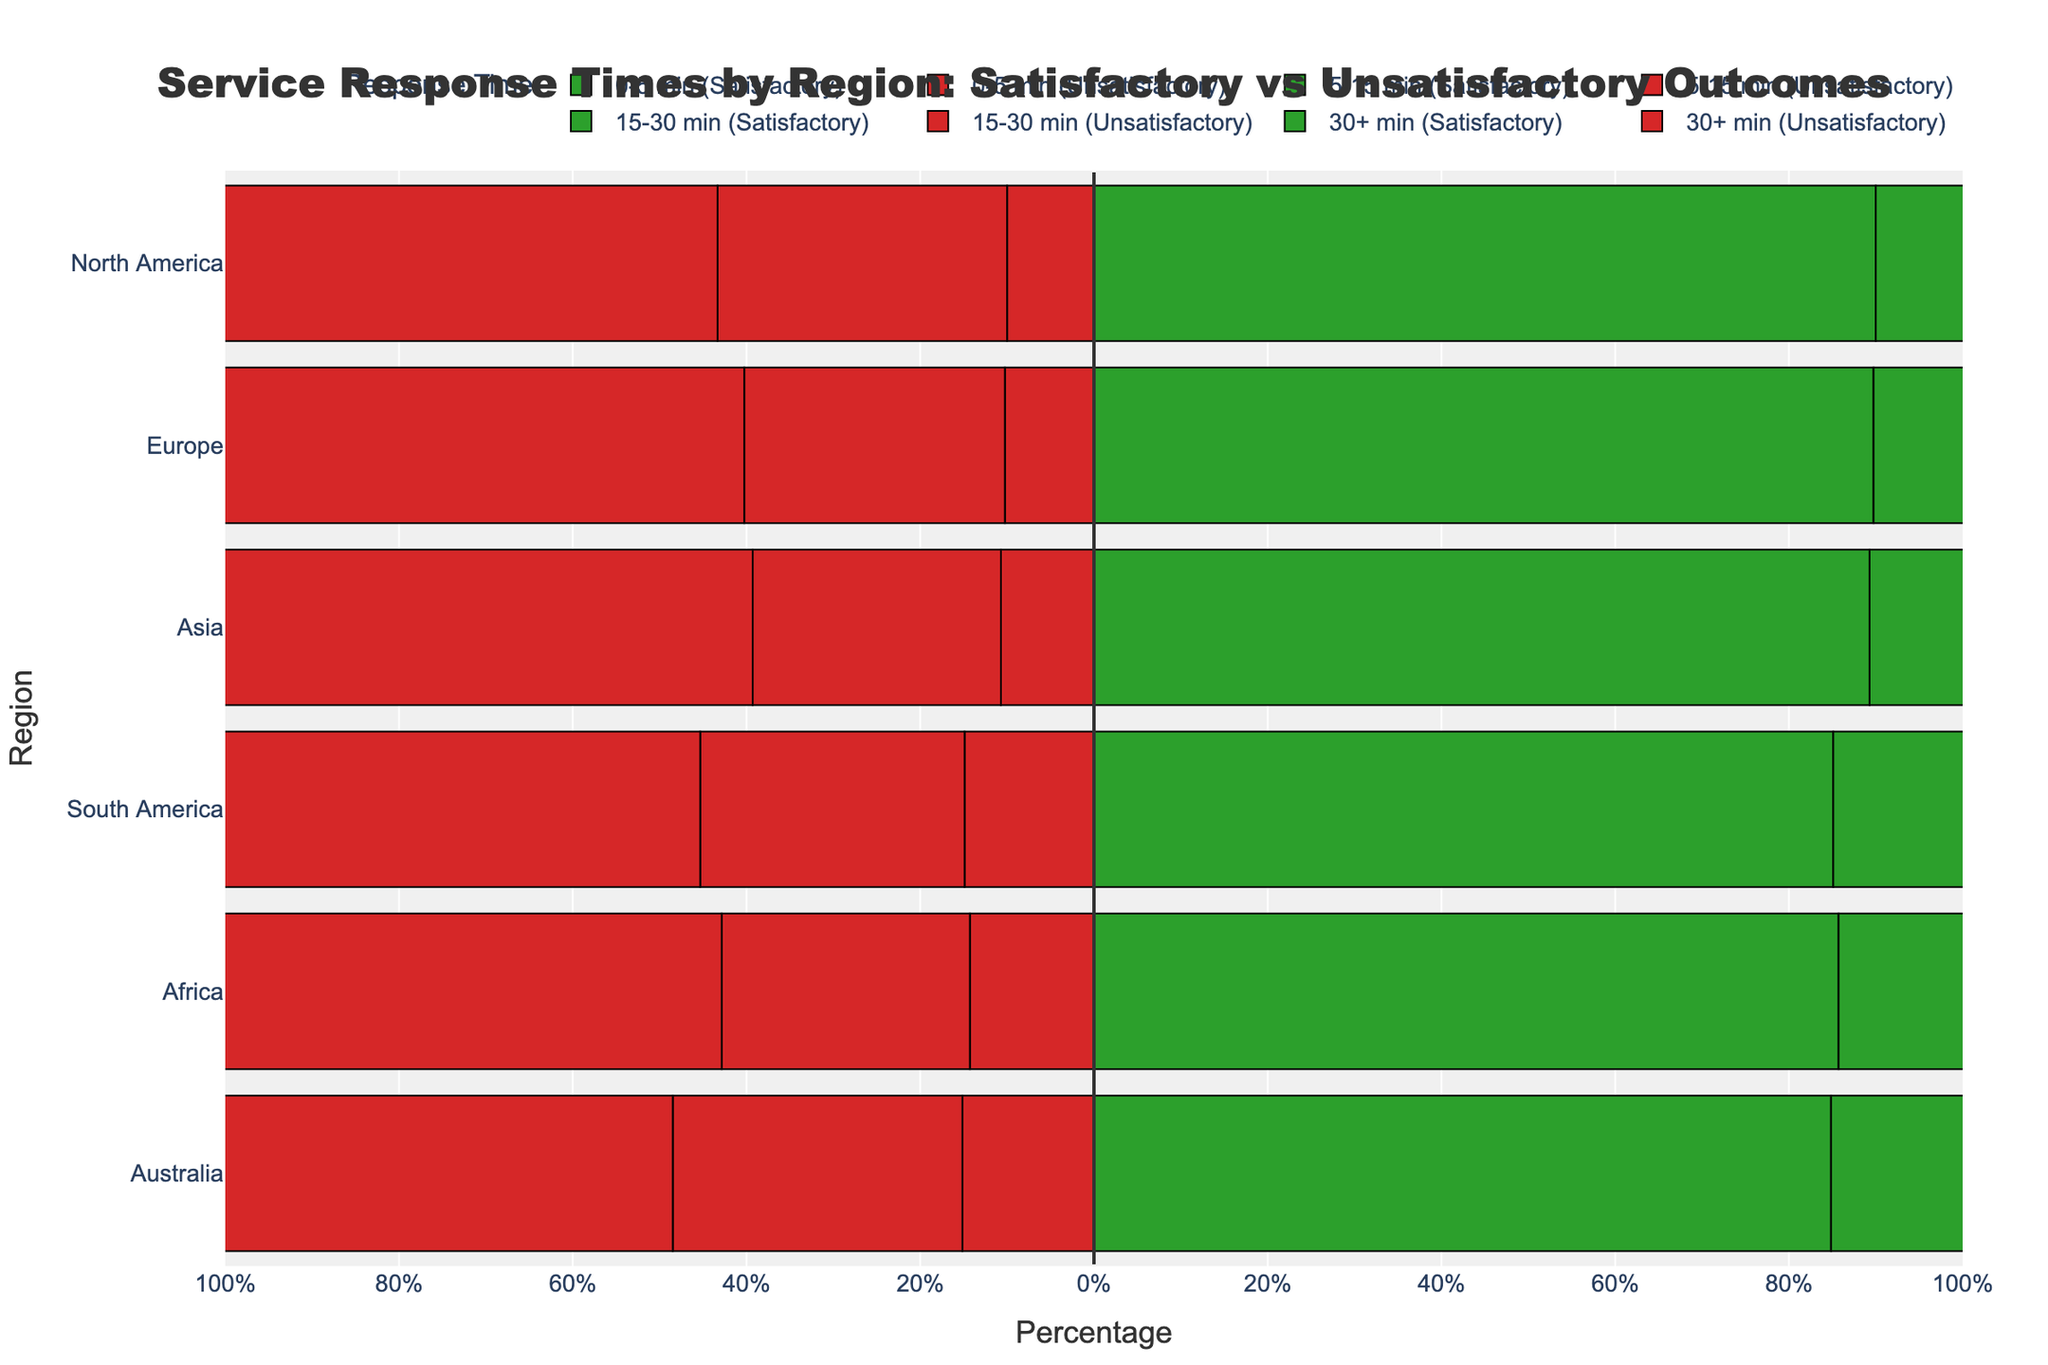Which region has the highest percentage of satisfactory responses in the 0-5 min category? The figure shows bars colored in green for satisfactory responses in the 0-5 min category. Observing the lengths of these bars will reveal their relative percentages.
Answer: Asia Which region has the highest percentage of unsatisfactory responses in the 30+ min category? The figure shows bars colored in red for unsatisfactory responses in the 30+ min category. Observing these bars and their lengths will reveal their relative percentages.
Answer: North America Compare the satisfactory response percentages between Europe and Africa for the 5-15 min category. Which is higher, and by how much? Reviewing the green bars for the 5-15 min category, we compare the lengths representing percentages for Europe and Africa. Calculate the difference between the two values.
Answer: Africa by 2% What is the sum of satisfactory responses for Australia across all response time categories? For Australia, identify the green bars for all response time categories and add their respective percentages.
Answer: 62.5% Which region has the lowest combined percentage of satisfactory and unsatisfactory responses for the 15-30 min category? Summing the absolute values of green (satisfactory) and red (unsatisfactory) bars for each region within the 15-30 min category will indicate the lowest combined percentage.
Answer: Australia In which region do satisfactory responses in the 0-5 min category exceed 70%? Identify green bars in the 0-5 min category and select the one(s) that exceed 70% on the x-axis.
Answer: Asia How does the percentage of unsatisfactory responses in Asia for the 30+ min category compare to the percentage in Europe? Look at the red bars for the 30+ min category for both Asia and Europe. Compare their lengths to see which is larger.
Answer: Asia is higher by 1% Calculate the average percentage of satisfactory responses for the 0-5 min category across all regions. Extract green bar percentages for all regions in the 0-5 min category, sum them up, and divide by the number of regions.
Answer: 30.8% What is the difference in unsatisfactory response percentages between South America and North America in the 5-15 min category? For the 5-15 min category, compare and calculate the difference in red bar lengths between South America and North America.
Answer: 1.25% Identify any region where the percentage of satisfactory responses is greater for the 30+ min category than for the 15-30 min category. Compare green bars for the 30+ min and 15-30 min categories across all regions. Look for any region with a longer green bar in the 30+ min category.
Answer: None 